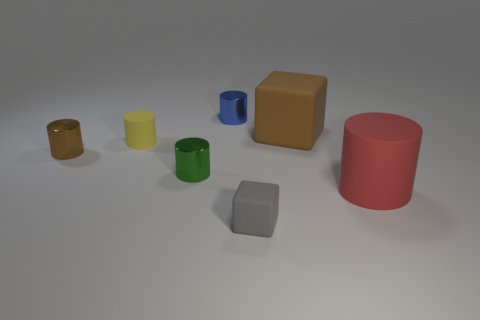Are there any objects of the same color as the big cube?
Provide a short and direct response. Yes. How many other things are the same shape as the brown shiny object?
Give a very brief answer. 4. There is a small thing that is on the right side of the yellow matte object and left of the blue metallic object; what shape is it?
Ensure brevity in your answer.  Cylinder. There is a matte object that is left of the tiny gray rubber thing; what size is it?
Ensure brevity in your answer.  Small. Do the yellow matte thing and the red object have the same size?
Your answer should be very brief. No. Are there fewer small brown metallic cylinders in front of the gray matte block than tiny rubber objects that are right of the small blue cylinder?
Provide a succinct answer. Yes. What size is the metal thing that is both in front of the blue metallic cylinder and on the right side of the tiny yellow matte thing?
Keep it short and to the point. Small. There is a big object that is right of the large matte object that is behind the green thing; is there a red matte object that is on the right side of it?
Provide a short and direct response. No. Are any tiny gray rubber cylinders visible?
Ensure brevity in your answer.  No. Are there more large things that are behind the tiny matte cylinder than big red things to the left of the big brown cube?
Offer a terse response. Yes. 